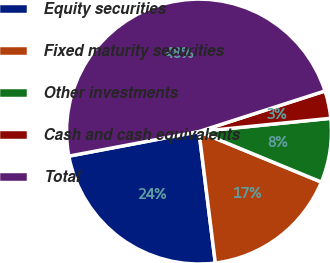Convert chart. <chart><loc_0><loc_0><loc_500><loc_500><pie_chart><fcel>Equity securities<fcel>Fixed maturity securities<fcel>Other investments<fcel>Cash and cash equivalents<fcel>Total<nl><fcel>24.0%<fcel>16.8%<fcel>7.83%<fcel>3.36%<fcel>48.01%<nl></chart> 